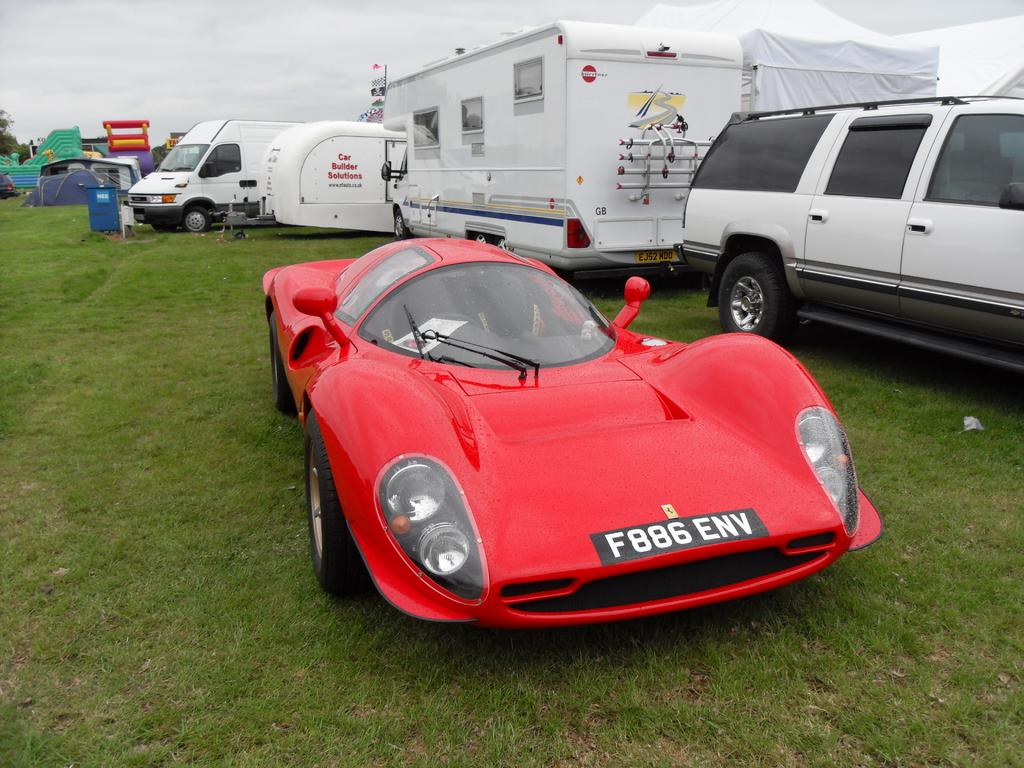What type of vehicle is the main subject of the image? There is a red car in the image. What is the color of the grass at the bottom of the image? The grass at the bottom of the image is green. What other types of vehicles can be seen in the background of the image? There are many vans and a truck in the background of the image. What is visible in the sky at the top of the image? There are clouds visible in the sky at the top of the image. What type of sign can be seen on the red car in the image? There is no sign visible on the red car in the image. What kind of bone is present in the image? There is no bone present in the image. 